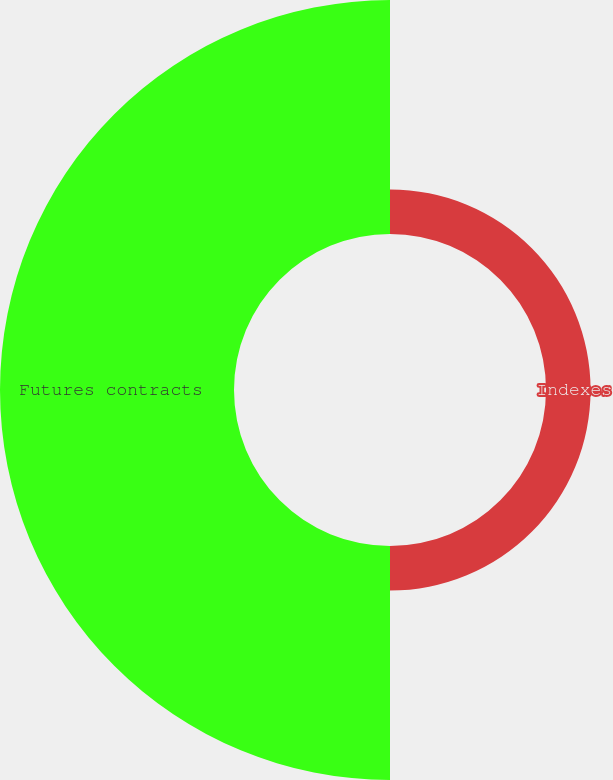<chart> <loc_0><loc_0><loc_500><loc_500><pie_chart><fcel>Indexes<fcel>Futures contracts<nl><fcel>16.0%<fcel>84.0%<nl></chart> 